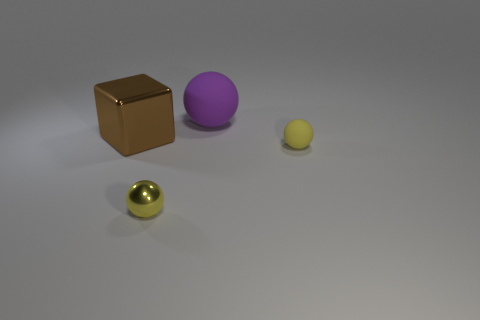If these objects were part of a game, what could their purpose be? In a hypothetical game scenario, the objects could represent different elements or resources. For example, the golden sphere might be a high-value item like a coin or a power-up due to its lustrous appearance. The brown cube could serve as a building block for constructing structures or barriers. The purple sphere might represent an orb with special abilities or energy, while the smaller yellow sphere could be a basic unit of currency or a lesser power-up. 